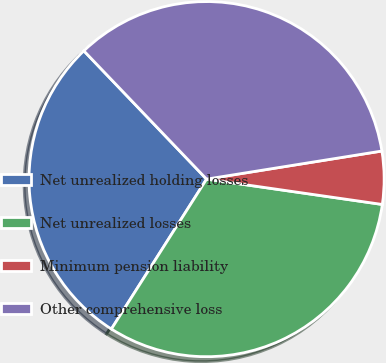Convert chart to OTSL. <chart><loc_0><loc_0><loc_500><loc_500><pie_chart><fcel>Net unrealized holding losses<fcel>Net unrealized losses<fcel>Minimum pension liability<fcel>Other comprehensive loss<nl><fcel>28.85%<fcel>31.73%<fcel>4.81%<fcel>34.62%<nl></chart> 